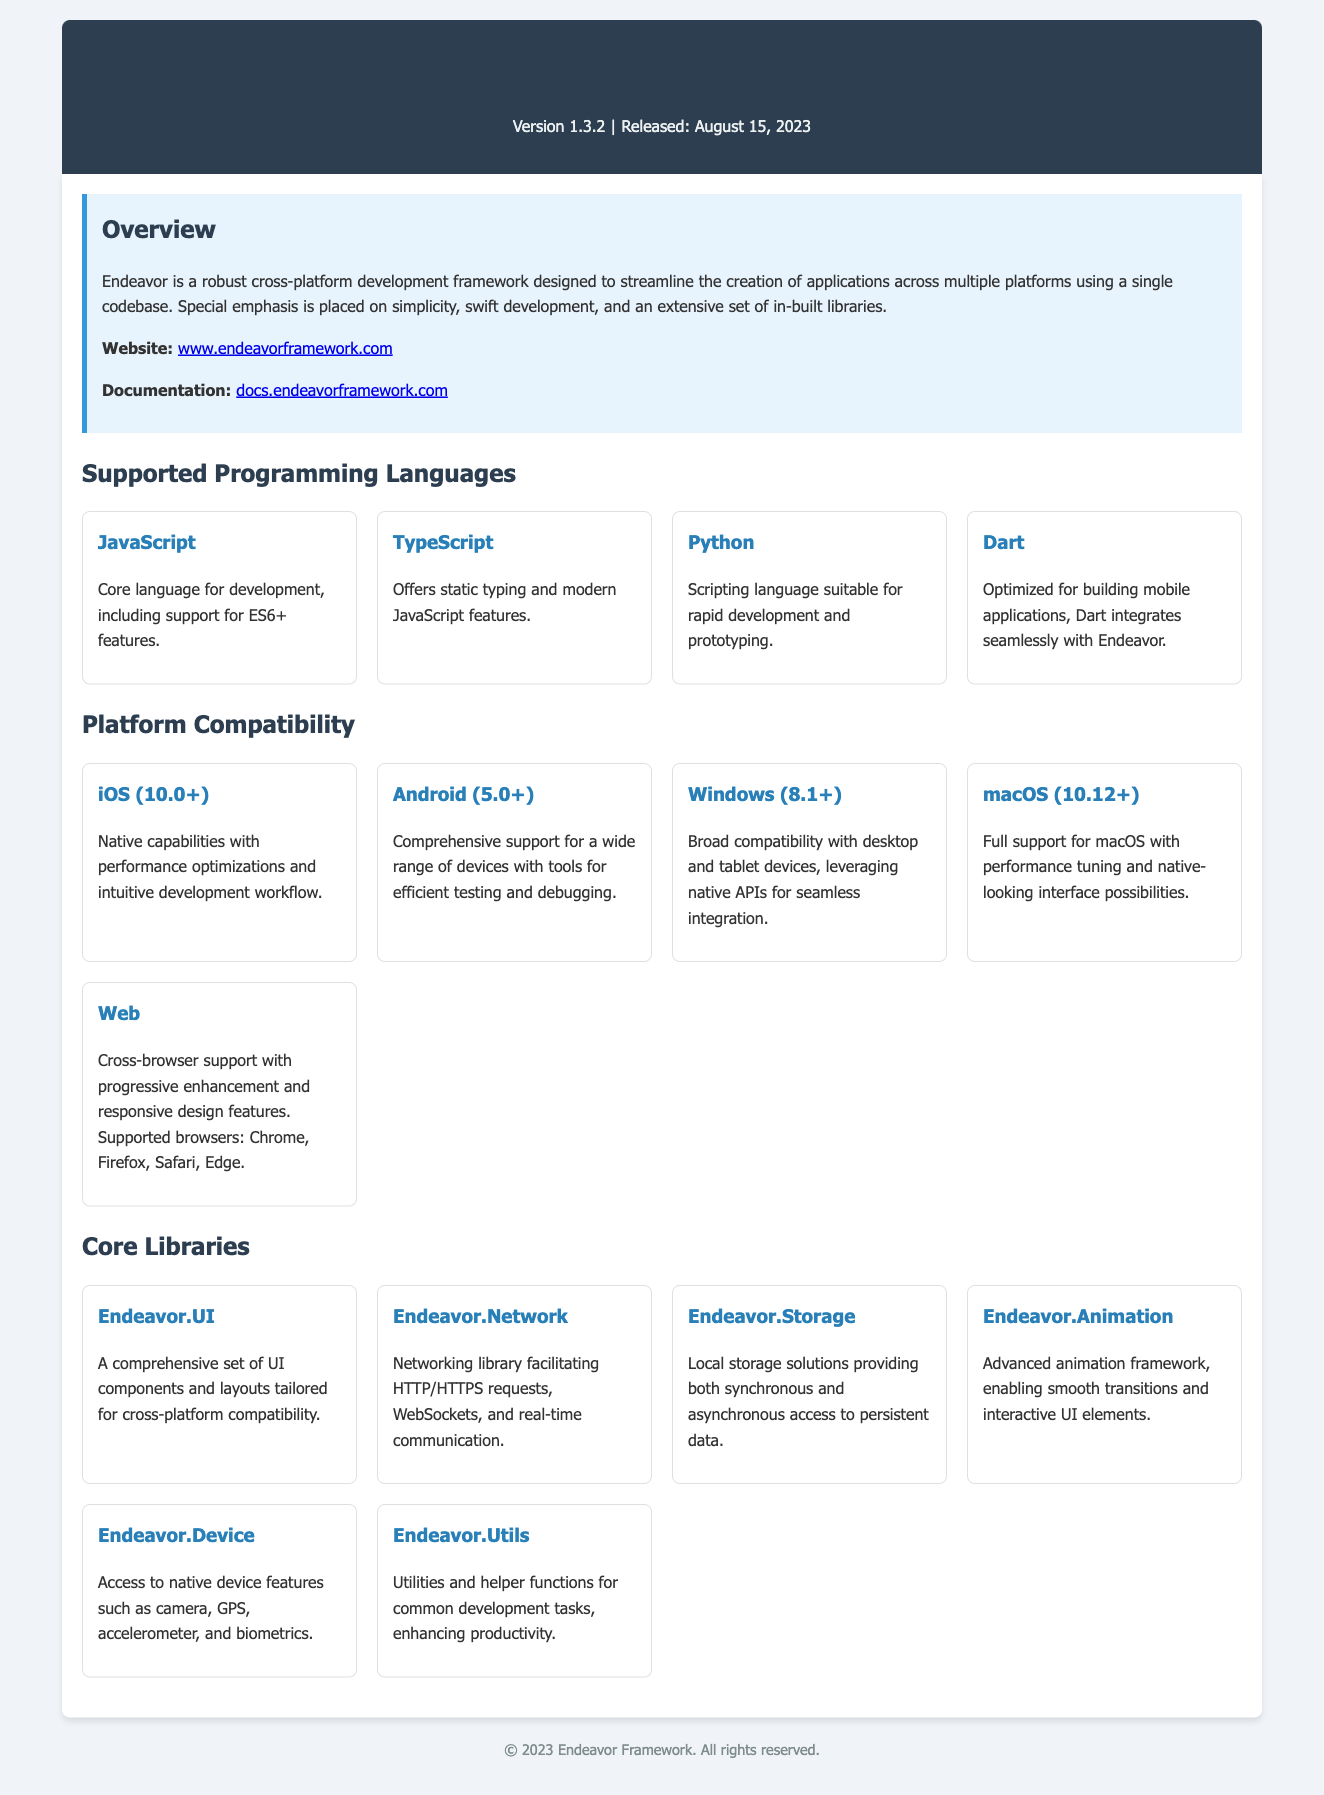What is the version of the Endeavor Framework? The document states that the version of the Endeavor Framework is included in the header section.
Answer: 1.3.2 What is the release date of the Endeavor Framework? The release date is mentioned in the header section of the document.
Answer: August 15, 2023 Which programming language offers static typing? The document lists programming languages with descriptions, specifying which ones provide static typing.
Answer: TypeScript What platforms are supported by the Endeavor Framework? The document includes a section detailing all compatible platforms within the framework.
Answer: iOS, Android, Windows, macOS, Web How many core libraries are bundled with the Endeavor Framework? The document lists the core libraries in a section and can be counted for the total.
Answer: Six What library facilitates HTTP/HTTPS requests? The document categorizes core libraries and identifies which one handles networking requests.
Answer: Endeavor.Network Which operating system requires a minimum version of 10.0? The document specifies the minimum version required for various platforms in the compatibility section.
Answer: iOS What is the primary design focus of the Endeavor Framework? The overarching goals of the framework are outlined in the overview section.
Answer: Simplicity What type of components does Endeavor.UI provide? The libraries section describes the type of components each library offers.
Answer: UI components 